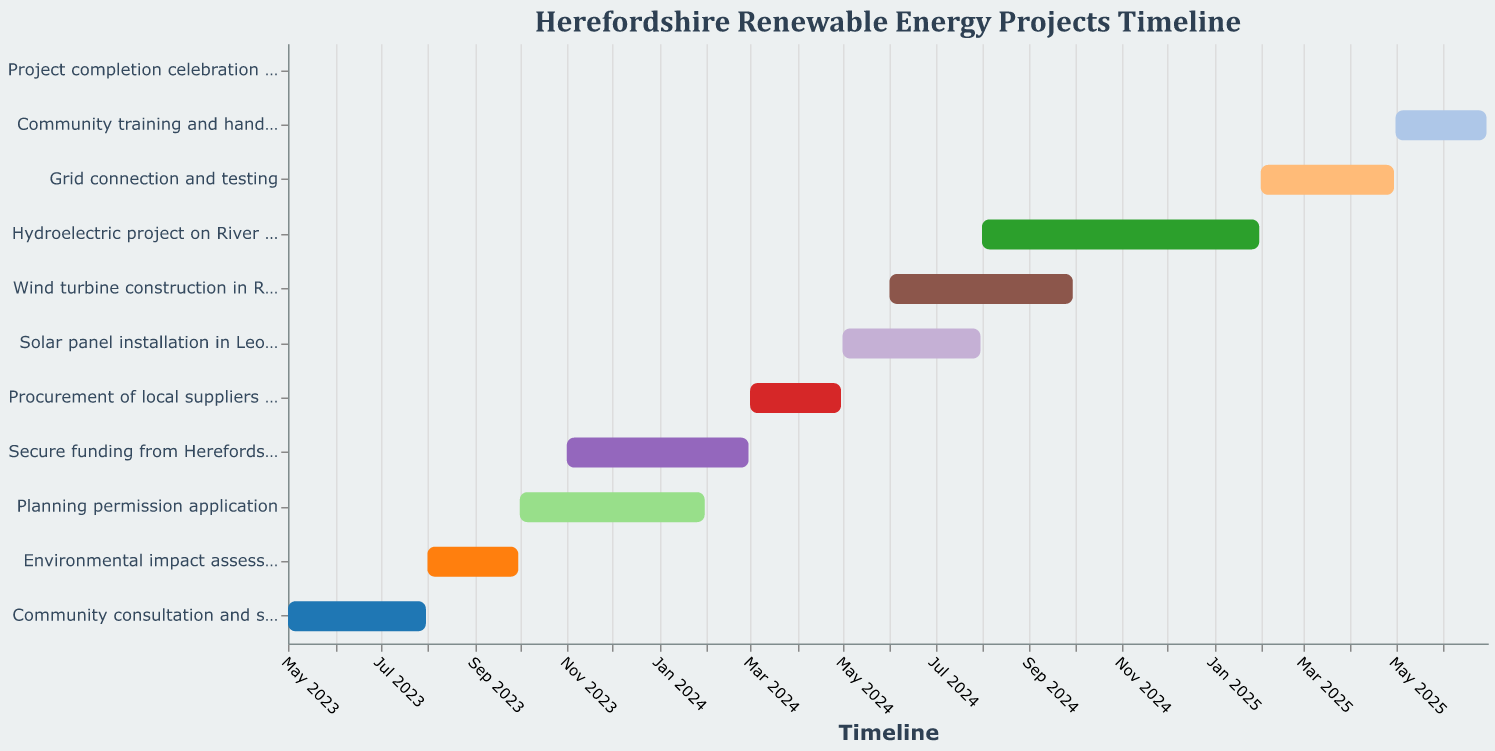What is the duration of the project from start to completion? The project starts on May 1, 2023, and ends with the project completion celebration on July 1, 2025. To find the total duration, calculate the time between these two dates.
Answer: Approximately 26 months When does the planning permission application process begin and end? According to the Gantt chart, the planning permission application begins on October 1, 2023, and ends on January 31, 2024.
Answer: October 1, 2023, to January 31, 2024 Which task has the longest duration, and how long does it last? By examining the durations in the figure, the hydroelectric project on River Wye has the longest duration of 184 days.
Answer: Hydroelectric project on River Wye, 184 days How many months are devoted to grid connection and testing? The grid connection and testing phase starts on February 1, 2025, and finishes on April 30, 2025. This duration encompasses February, March, and April.
Answer: 3 months Which two tasks overlap in their timelines during June 2024? Referring to the chart, the solar panel installation in Leominster and the wind turbine construction in Ross-on-Wye both occur in June 2024.
Answer: Solar panel installation in Leominster and wind turbine construction in Ross-on-Wye What task immediately follows the environmental impact assessment? The task that follows the environmental impact assessment is the planning permission application, which starts on October 1, 2023.
Answer: Planning permission application Is there any task that takes exactly 61 days to complete? Both the environmental impact assessment (August 1, 2023 – September 30, 2023) and the procurement of local suppliers and contractors (March 1, 2024 – April 30, 2024) take exactly 61 days each.
Answer: Environmental impact assessment and procurement of local suppliers and contractors Which task directly precedes the wind turbine construction in Ross-on-Wye? According to the Gantt chart, the task before the wind turbine construction in Ross-on-Wye is the solar panel installation in Leominster, which begins in May 2024, and overlaps by one month.
Answer: Solar panel installation in Leominster How long is the timeline for community training and handover? The community training and handover phase starts on May 1, 2025, and ends on June 30, 2025, resulting in a timeline of 61 days.
Answer: 61 days 